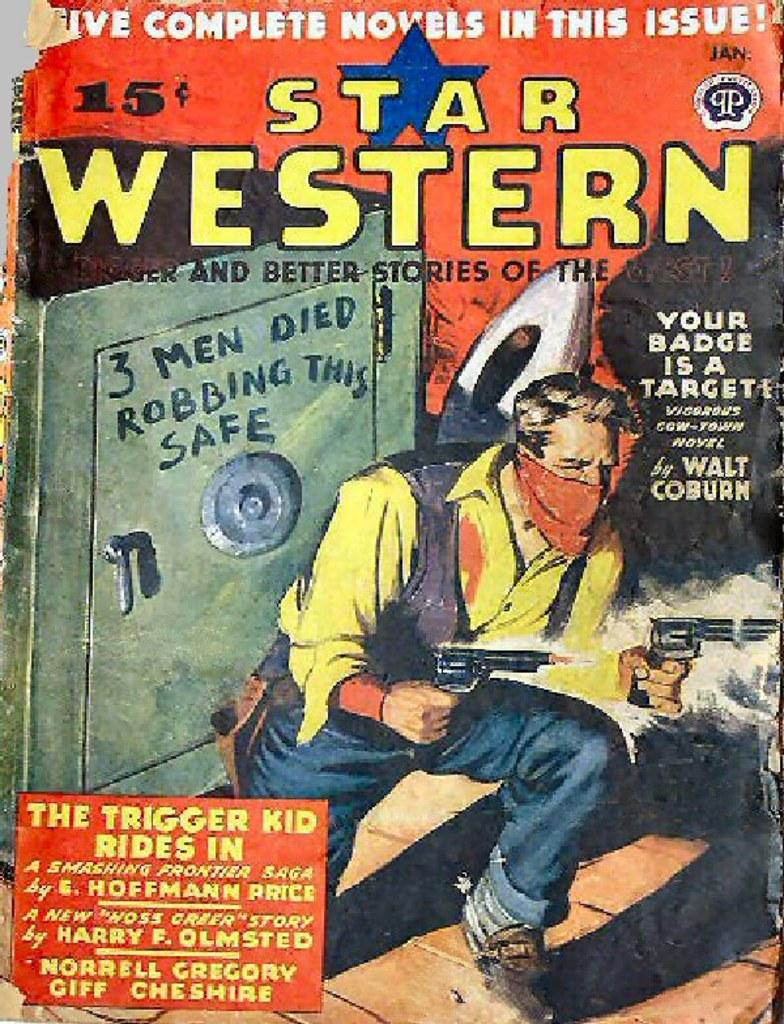<image>
Share a concise interpretation of the image provided. The Star Western book novel stories which includes five novels. 